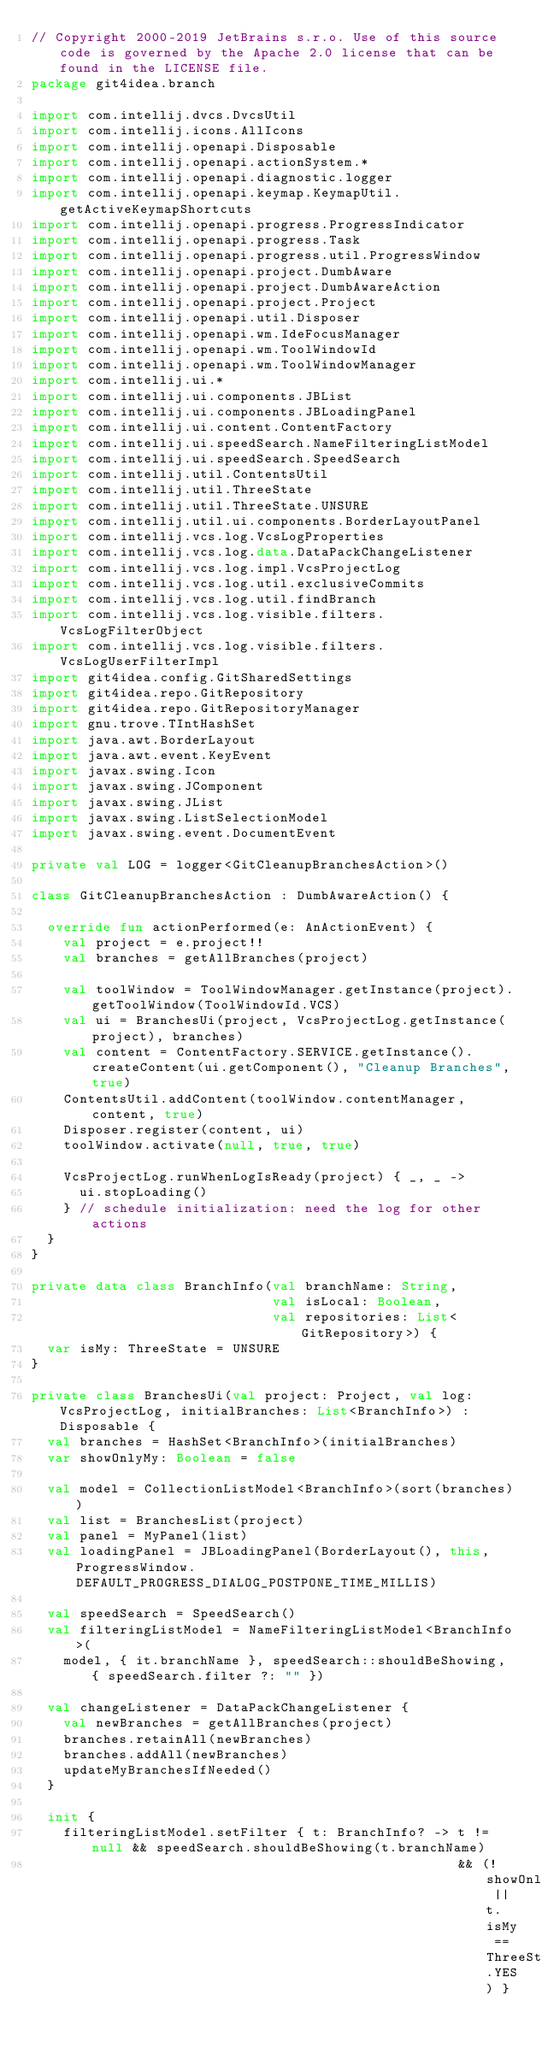<code> <loc_0><loc_0><loc_500><loc_500><_Kotlin_>// Copyright 2000-2019 JetBrains s.r.o. Use of this source code is governed by the Apache 2.0 license that can be found in the LICENSE file.
package git4idea.branch

import com.intellij.dvcs.DvcsUtil
import com.intellij.icons.AllIcons
import com.intellij.openapi.Disposable
import com.intellij.openapi.actionSystem.*
import com.intellij.openapi.diagnostic.logger
import com.intellij.openapi.keymap.KeymapUtil.getActiveKeymapShortcuts
import com.intellij.openapi.progress.ProgressIndicator
import com.intellij.openapi.progress.Task
import com.intellij.openapi.progress.util.ProgressWindow
import com.intellij.openapi.project.DumbAware
import com.intellij.openapi.project.DumbAwareAction
import com.intellij.openapi.project.Project
import com.intellij.openapi.util.Disposer
import com.intellij.openapi.wm.IdeFocusManager
import com.intellij.openapi.wm.ToolWindowId
import com.intellij.openapi.wm.ToolWindowManager
import com.intellij.ui.*
import com.intellij.ui.components.JBList
import com.intellij.ui.components.JBLoadingPanel
import com.intellij.ui.content.ContentFactory
import com.intellij.ui.speedSearch.NameFilteringListModel
import com.intellij.ui.speedSearch.SpeedSearch
import com.intellij.util.ContentsUtil
import com.intellij.util.ThreeState
import com.intellij.util.ThreeState.UNSURE
import com.intellij.util.ui.components.BorderLayoutPanel
import com.intellij.vcs.log.VcsLogProperties
import com.intellij.vcs.log.data.DataPackChangeListener
import com.intellij.vcs.log.impl.VcsProjectLog
import com.intellij.vcs.log.util.exclusiveCommits
import com.intellij.vcs.log.util.findBranch
import com.intellij.vcs.log.visible.filters.VcsLogFilterObject
import com.intellij.vcs.log.visible.filters.VcsLogUserFilterImpl
import git4idea.config.GitSharedSettings
import git4idea.repo.GitRepository
import git4idea.repo.GitRepositoryManager
import gnu.trove.TIntHashSet
import java.awt.BorderLayout
import java.awt.event.KeyEvent
import javax.swing.Icon
import javax.swing.JComponent
import javax.swing.JList
import javax.swing.ListSelectionModel
import javax.swing.event.DocumentEvent

private val LOG = logger<GitCleanupBranchesAction>()

class GitCleanupBranchesAction : DumbAwareAction() {

  override fun actionPerformed(e: AnActionEvent) {
    val project = e.project!!
    val branches = getAllBranches(project)

    val toolWindow = ToolWindowManager.getInstance(project).getToolWindow(ToolWindowId.VCS)
    val ui = BranchesUi(project, VcsProjectLog.getInstance(project), branches)
    val content = ContentFactory.SERVICE.getInstance().createContent(ui.getComponent(), "Cleanup Branches", true)
    ContentsUtil.addContent(toolWindow.contentManager, content, true)
    Disposer.register(content, ui)
    toolWindow.activate(null, true, true)

    VcsProjectLog.runWhenLogIsReady(project) { _, _ ->
      ui.stopLoading()
    } // schedule initialization: need the log for other actions
  }
}

private data class BranchInfo(val branchName: String,
                              val isLocal: Boolean,
                              val repositories: List<GitRepository>) {
  var isMy: ThreeState = UNSURE
}

private class BranchesUi(val project: Project, val log: VcsProjectLog, initialBranches: List<BranchInfo>) : Disposable {
  val branches = HashSet<BranchInfo>(initialBranches)
  var showOnlyMy: Boolean = false

  val model = CollectionListModel<BranchInfo>(sort(branches))
  val list = BranchesList(project)
  val panel = MyPanel(list)
  val loadingPanel = JBLoadingPanel(BorderLayout(), this, ProgressWindow.DEFAULT_PROGRESS_DIALOG_POSTPONE_TIME_MILLIS)

  val speedSearch = SpeedSearch()
  val filteringListModel = NameFilteringListModel<BranchInfo>(
    model, { it.branchName }, speedSearch::shouldBeShowing, { speedSearch.filter ?: "" })

  val changeListener = DataPackChangeListener {
    val newBranches = getAllBranches(project)
    branches.retainAll(newBranches)
    branches.addAll(newBranches)
    updateMyBranchesIfNeeded()
  }

  init {
    filteringListModel.setFilter { t: BranchInfo? -> t != null && speedSearch.shouldBeShowing(t.branchName)
                                                     && (!showOnlyMy || t.isMy == ThreeState.YES) }
</code> 